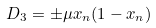Convert formula to latex. <formula><loc_0><loc_0><loc_500><loc_500>D _ { 3 } = \pm \mu x _ { n } ( 1 - x _ { n } )</formula> 